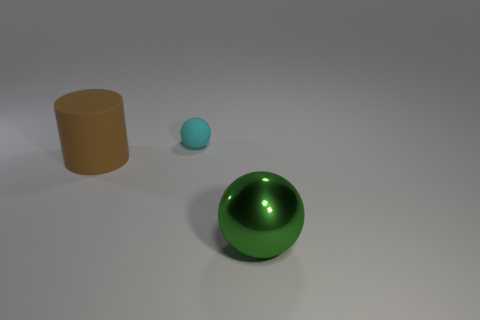Subtract 1 cylinders. How many cylinders are left? 0 Subtract all purple cylinders. Subtract all red blocks. How many cylinders are left? 1 Subtract all gray cylinders. How many cyan spheres are left? 1 Subtract all red blocks. Subtract all big green things. How many objects are left? 2 Add 2 green metal objects. How many green metal objects are left? 3 Add 2 large green matte spheres. How many large green matte spheres exist? 2 Add 1 small gray metallic objects. How many objects exist? 4 Subtract 0 brown spheres. How many objects are left? 3 Subtract all spheres. How many objects are left? 1 